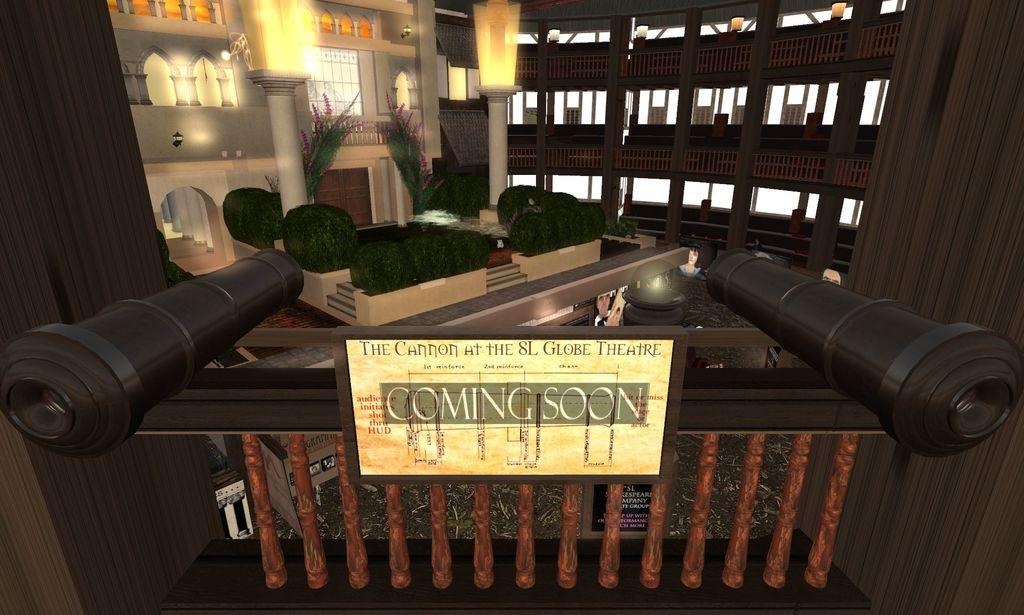What type of image is being described? The image is animated. What is written or displayed on the board in the image? There is a board with text in the image. Can you describe any objects visible in the image? There are objects visible in the image. What type of architectural feature can be seen in the image? There is railing in the image. What type of vegetation is present in the image? There are shrubs in the image. What other structural elements can be seen in the image? There are pillars in the image. What can be seen in the background of the image? There are lights in the background of the image. How does the cannon affect the rainstorm in the image? There is no cannon or rainstorm present in the image. What is the belief system of the characters in the image? The image does not depict any characters or convey any belief system. 